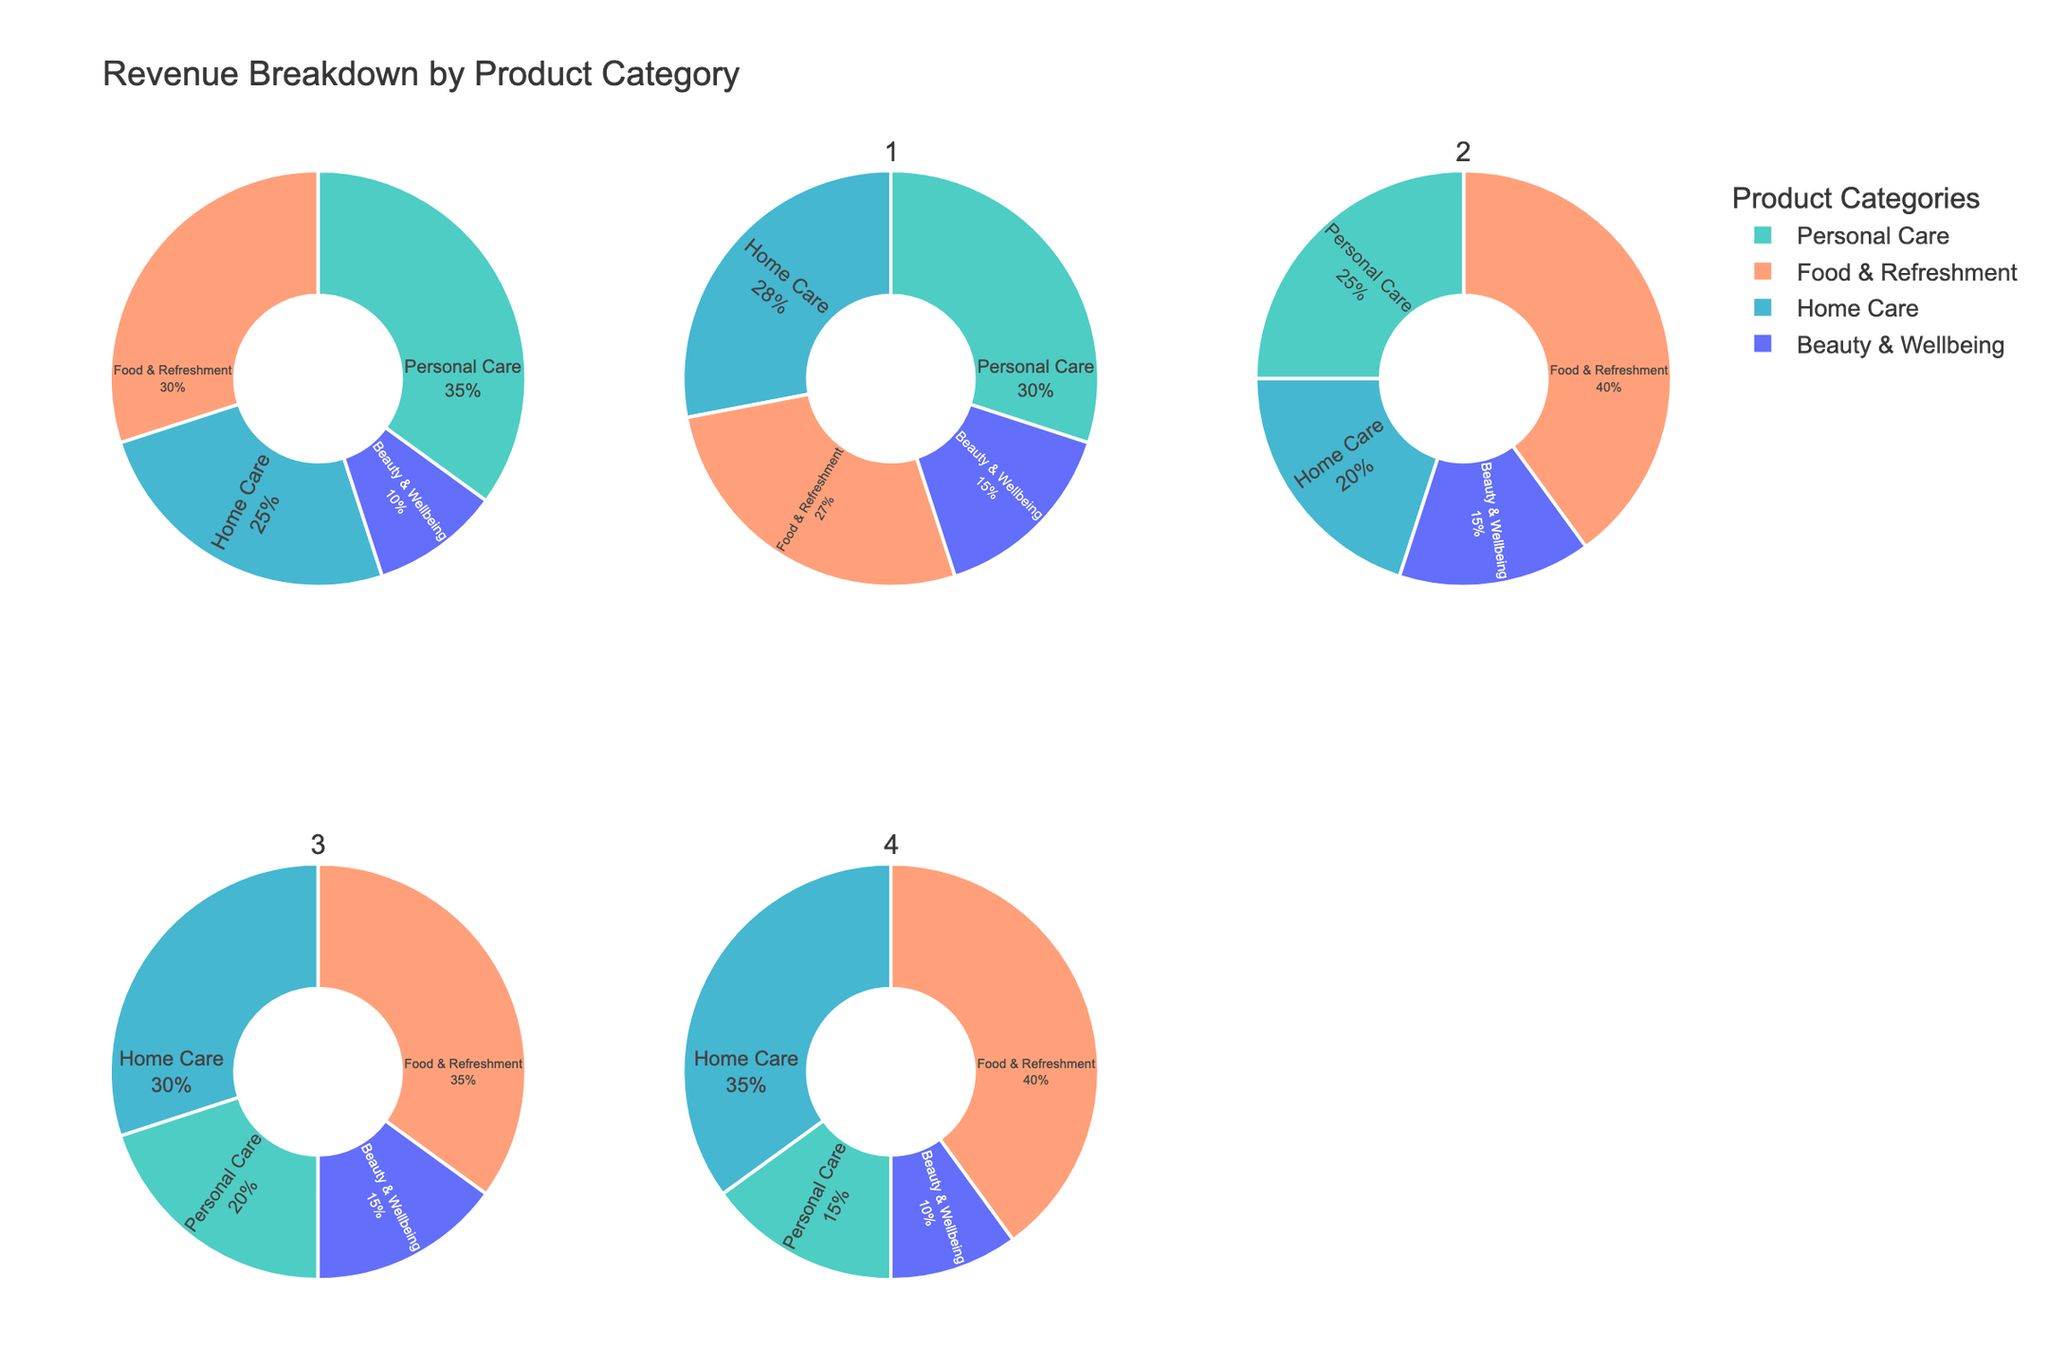What is the title of the figure? The title of a figure is typically displayed at the top and provides a concise summary of what the figure represents. In this case, the title is located at the top center of the figure.
Answer: Revenue Breakdown by Product Category Which region has the highest percentage of revenue from Personal Care? By observing the pie charts, you can check the section labeled "Personal Care" for each region and compare their percentages. The region with the highest percentage in that section will be the answer.
Answer: North America How does the revenue percentage from Home Care in Europe compare to that in Asia Pacific? Identify the percentages in the Home Care sections of the pie charts for both regions. Then, simply compare the two percentages to determine the relationship (e.g., greater than, less than).
Answer: Higher in Europe Which two regions have an equal percentage of revenue from Beauty & Wellbeing? Look at the Beauty & Wellbeing sections of each pie chart and check the percentages. Identify any two regions that have the same percentage.
Answer: Asia Pacific and Latin America What is the average percentage of revenue from Food & Refreshment across all regions? Sum the percentages from the Food & Refreshment sections of all pie charts and divide by the number of regions to find the average. Sum: 30% + 27% + 40% + 35% + 40% = 172%. Average: 172% / 5 = 34.4%.
Answer: 34.4% Which category has the most uniform distribution of revenue percentages across all regions? Analyze the sections of each category across all regions. The category with the smallest variation in percentage values demonstrates the most uniform distribution.
Answer: Beauty & Wellbeing Which region dedicates the least revenue percentage to Beauty & Wellbeing? Check the Beauty & Wellbeing sections across all regions and identify the region with the smallest percentage.
Answer: North America In which region is the Food & Refreshment category's revenue closest to 30%? Look at each region's Food & Refreshment section and find the percentage nearest to 30%.
Answer: North America Is the percentage of revenue from Home Care higher in Africa & Middle East or North America? Compare the Home Care sections in both regions' pie charts to see which has the higher percentage.
Answer: Africa & Middle East What is the total percentage of revenue from Personal Care and Home Care in Latin America? Add the percentages of Personal Care and Home Care from the Latin America pie chart. Sum: 20% + 30% = 50%.
Answer: 50% 